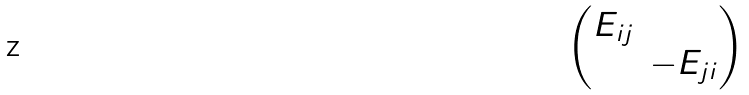Convert formula to latex. <formula><loc_0><loc_0><loc_500><loc_500>\begin{pmatrix} E _ { i j } & \\ & - E _ { j i } \end{pmatrix}</formula> 